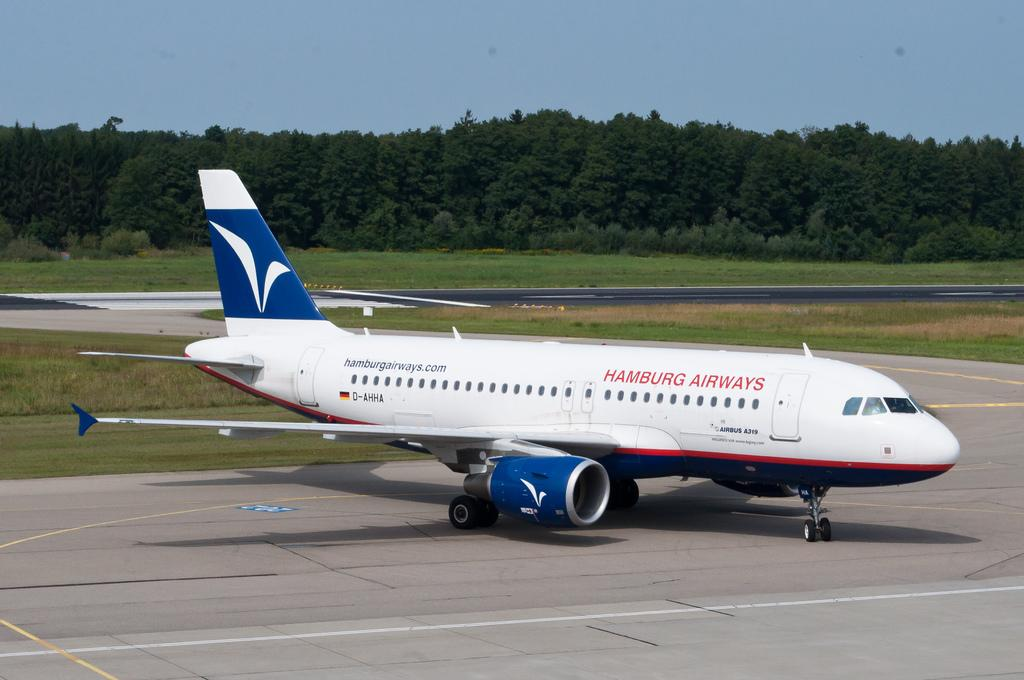What is located on the runway in the image? There is a plane on the runway in the image. What type of vegetation can be seen in the image? There are trees and grass visible in the image. What type of box can be seen dividing the pets in the image? There is no box or pets present in the image; it features a plane on the runway and trees and grass in the background. 